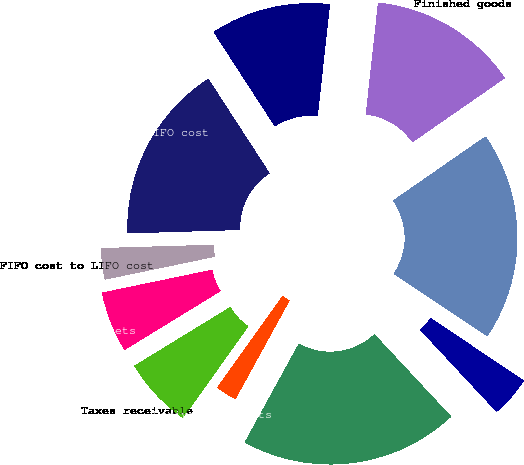<chart> <loc_0><loc_0><loc_500><loc_500><pie_chart><fcel>Accounts receivable<fcel>Allowance for doubtful<fcel>Total<fcel>Finished goods<fcel>Raw materials and parts<fcel>Inventories at FIFO cost<fcel>FIFO cost to LIFO cost<fcel>Prepaid assets<fcel>Taxes receivable<fcel>Derivative assets<nl><fcel>19.92%<fcel>3.69%<fcel>19.02%<fcel>13.61%<fcel>10.9%<fcel>16.31%<fcel>2.78%<fcel>5.49%<fcel>6.39%<fcel>1.88%<nl></chart> 